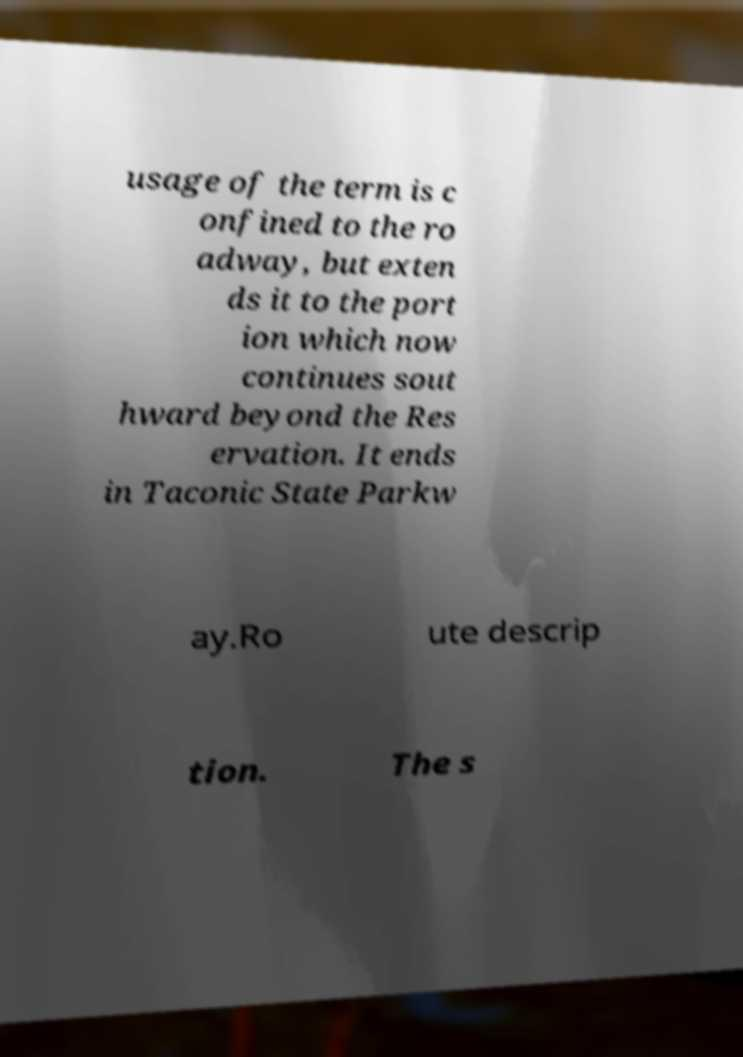Can you accurately transcribe the text from the provided image for me? usage of the term is c onfined to the ro adway, but exten ds it to the port ion which now continues sout hward beyond the Res ervation. It ends in Taconic State Parkw ay.Ro ute descrip tion. The s 